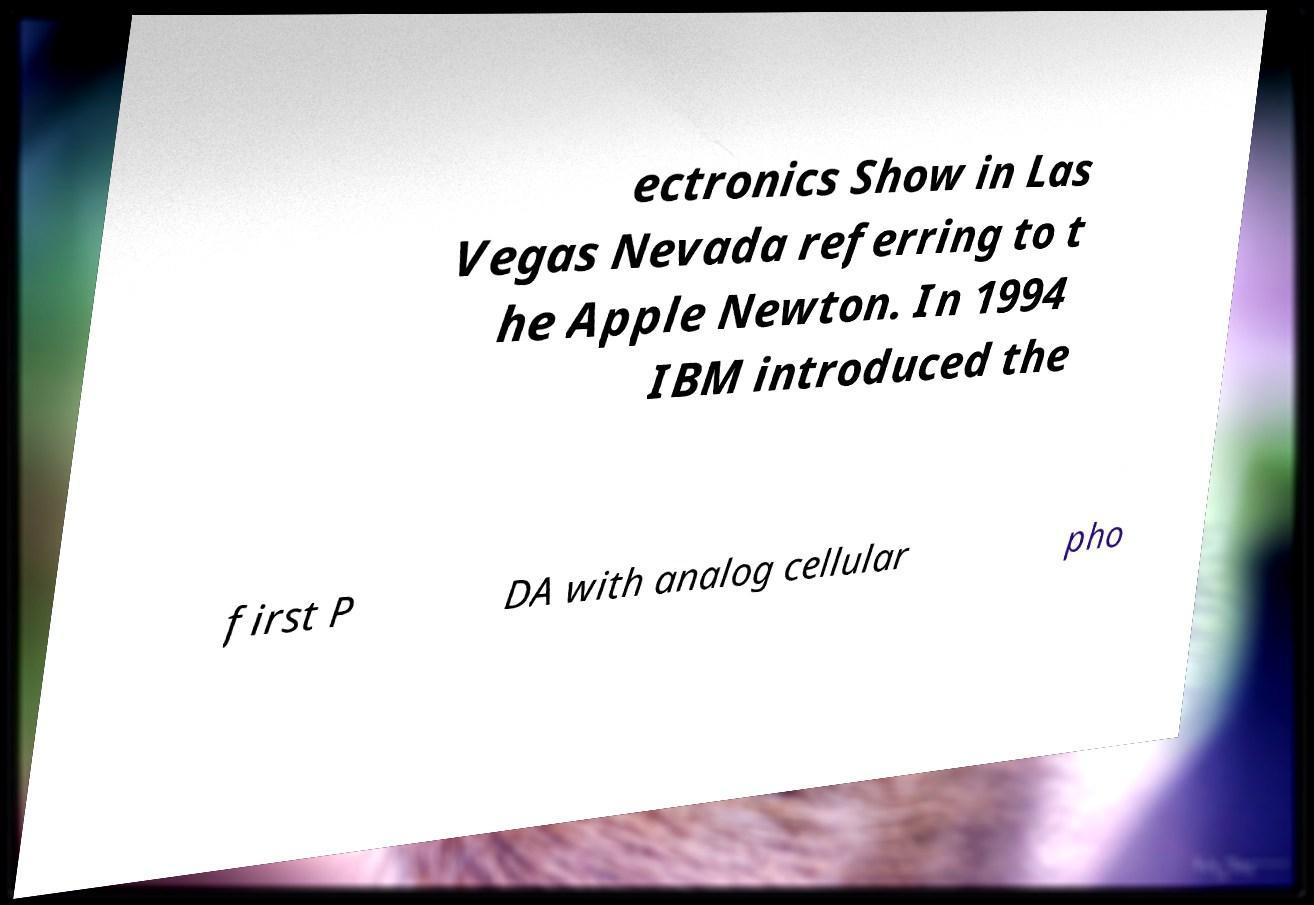Could you extract and type out the text from this image? ectronics Show in Las Vegas Nevada referring to t he Apple Newton. In 1994 IBM introduced the first P DA with analog cellular pho 